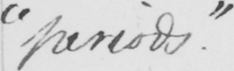Please provide the text content of this handwritten line. "periods." 